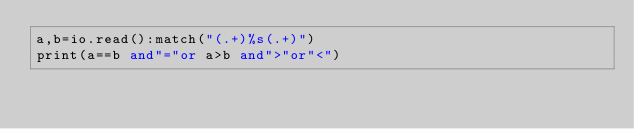Convert code to text. <code><loc_0><loc_0><loc_500><loc_500><_Lua_>a,b=io.read():match("(.+)%s(.+)")
print(a==b and"="or a>b and">"or"<")</code> 